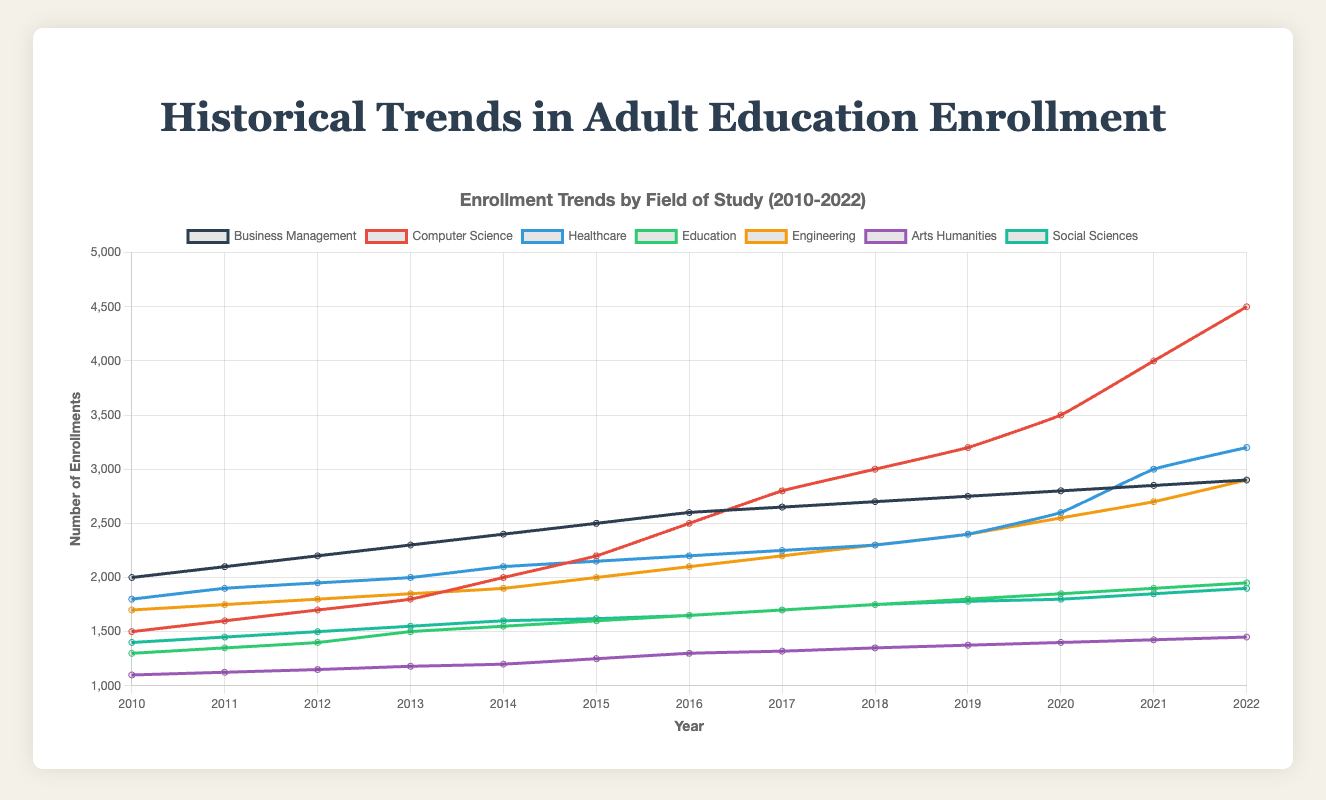What's the general trend in enrollments for Computer Science from 2010 to 2022? The line representing Computer Science shows a steady rise in enrollment numbers from 2010 to 2022, starting from approximately 1500 enrollments in 2010 and reaching around 4500 enrollments by 2022.
Answer: Increasing How has the enrollment for Arts Humanities changed between 2010 and 2022? The enrollment for Arts Humanities has shown a steady but modest increase from around 1100 enrollments in 2010 to approximately 1450 enrollments in 2022.
Answer: Gradual Increase Which field of study experienced the highest growth in enrollments from 2010 to 2022? By comparing the starting and ending points of each line, Computer Science shows the highest growth, increasing from 1500 enrollments in 2010 to 4500 enrollments in 2022. This growth of 3000 enrollments is the largest among all fields of study.
Answer: Computer Science What was the difference in enrollment between Engineering and Business Management in 2015? In 2015, the enrollment for Engineering was around 2000, while Business Management had about 2500 enrollments. The difference is calculated as 2500 - 2000 = 500.
Answer: 500 Which field had the least amount of enrollments in 2010, and how did its enrollment change by 2022? In 2010, Arts Humanities had the least enrollments with about 1100. By 2022, its enrollment increased to approximately 1450.
Answer: Arts Humanities, Increased What is the approximate average annual growth in enrollments for Healthcare between 2010 and 2022? To find the average annual growth, calculate the difference in enrollments between 2010 and 2022 and divide by the number of years. The growth is (3200 - 1800) / (2022 - 2010) = 1400 / 12 ≈ 116.67 enrollments per year.
Answer: 116.67 enrollments per year Compare the enrollment trends for Education and Social Sciences between 2010 and 2022. Both fields show a steady increase in enrollments. Education starts at 1300 in 2010 and ends at 1950 in 2022, increasing by 650. Social Sciences start at 1400 in 2010 and end at 1900 in 2022, increasing by 500.
Answer: Both increased, Education by 650, Social Sciences by 500 During which year did Healthcare see the most significant increase in enrollments? By examining the slopes of the lines, the steepest increase for Healthcare occurs between 2020 and 2021, where enrollments jump from around 2600 to 3000, an increase of 400.
Answer: Between 2020 and 2021 What's the difference between the highest and lowest enrollments across all fields in 2022? The highest enrollment in 2022 is for Computer Science with approximately 4500 enrollments, while the lowest is for Arts Humanities with about 1450 enrollments. The difference is 4500 - 1450 = 3050.
Answer: 3050 